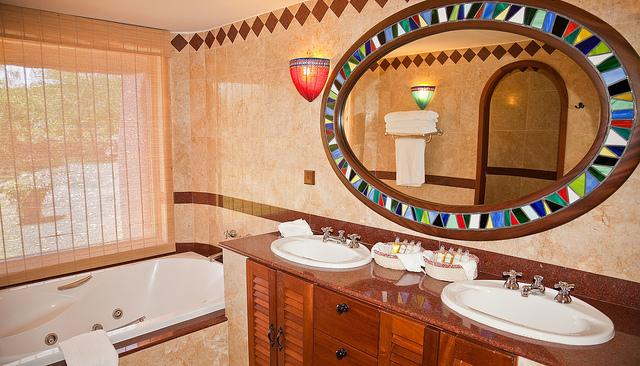What materials likely make up the colorful frame of the mirror?

Choices:
A) metal
B) terra cotta
C) porcelain
D) concrete porcelain 